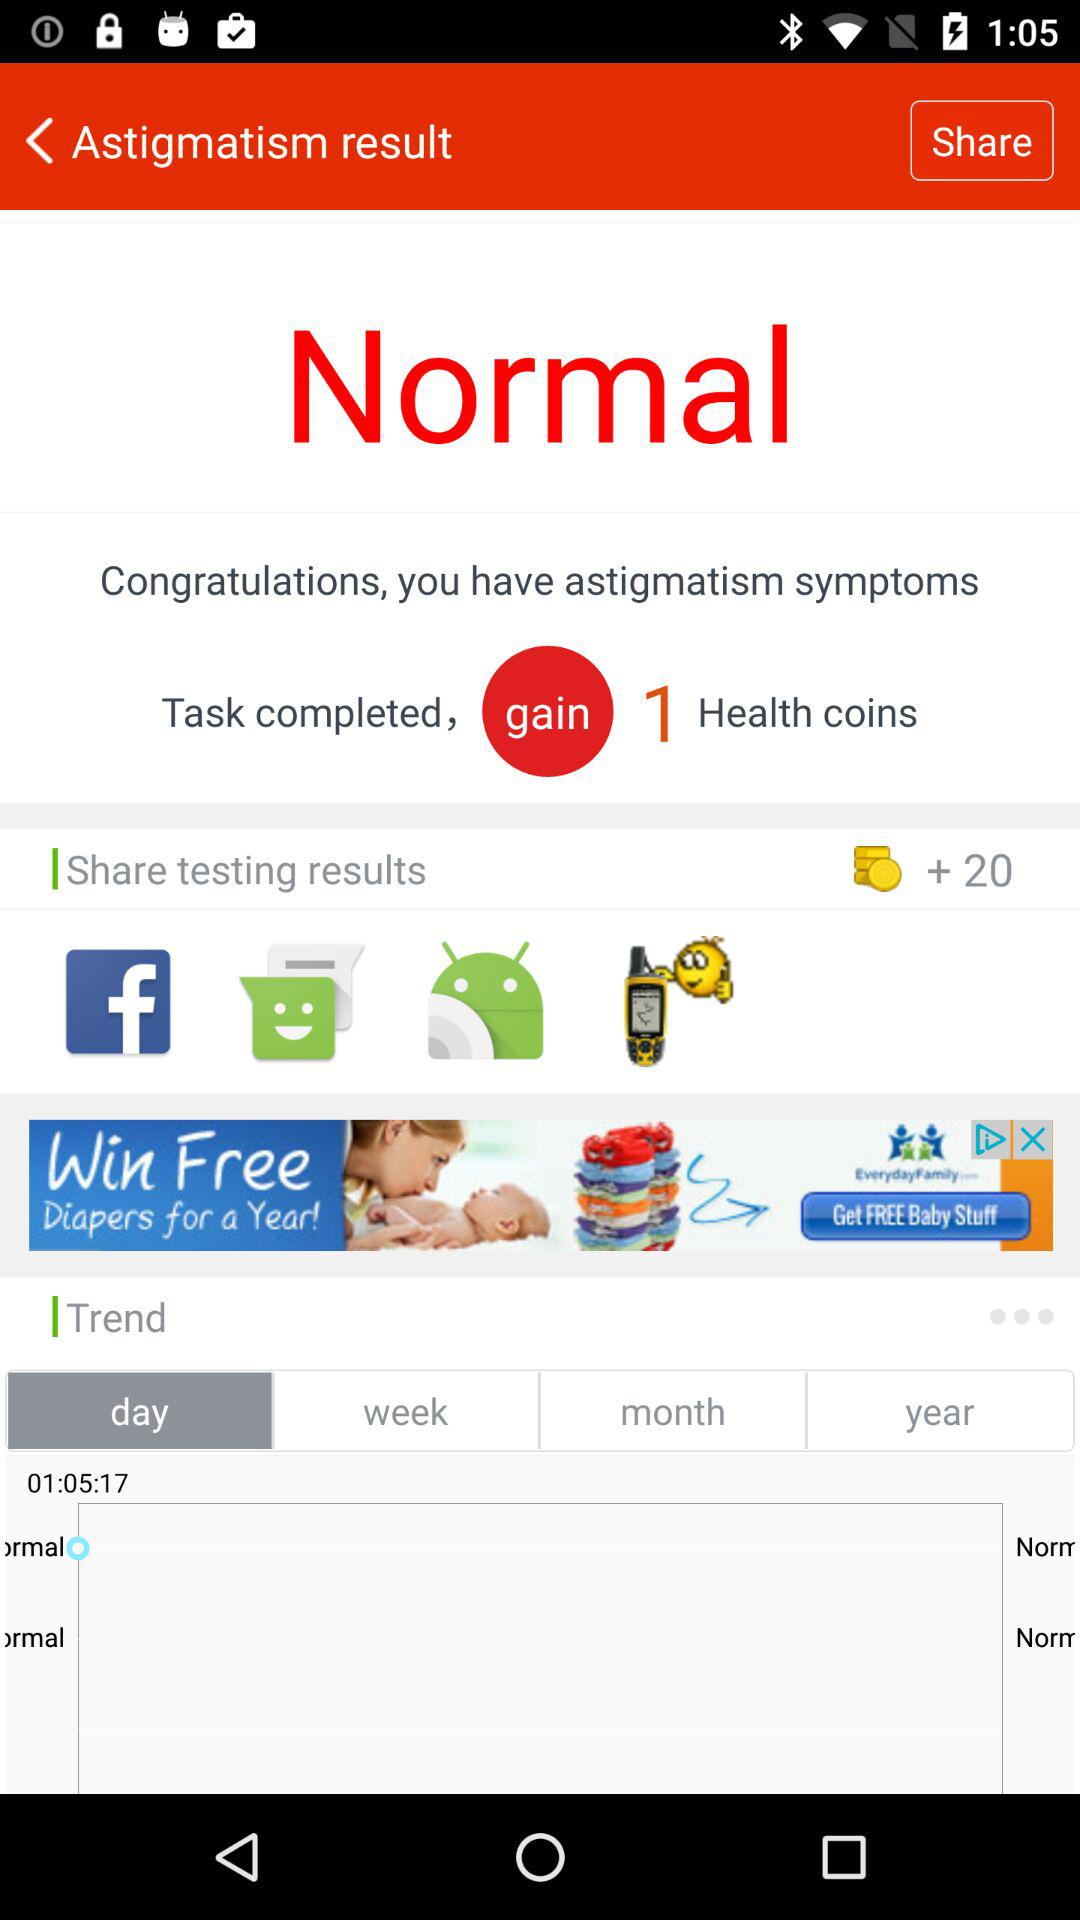How many more health coins do I have than I had before?
Answer the question using a single word or phrase. 1 